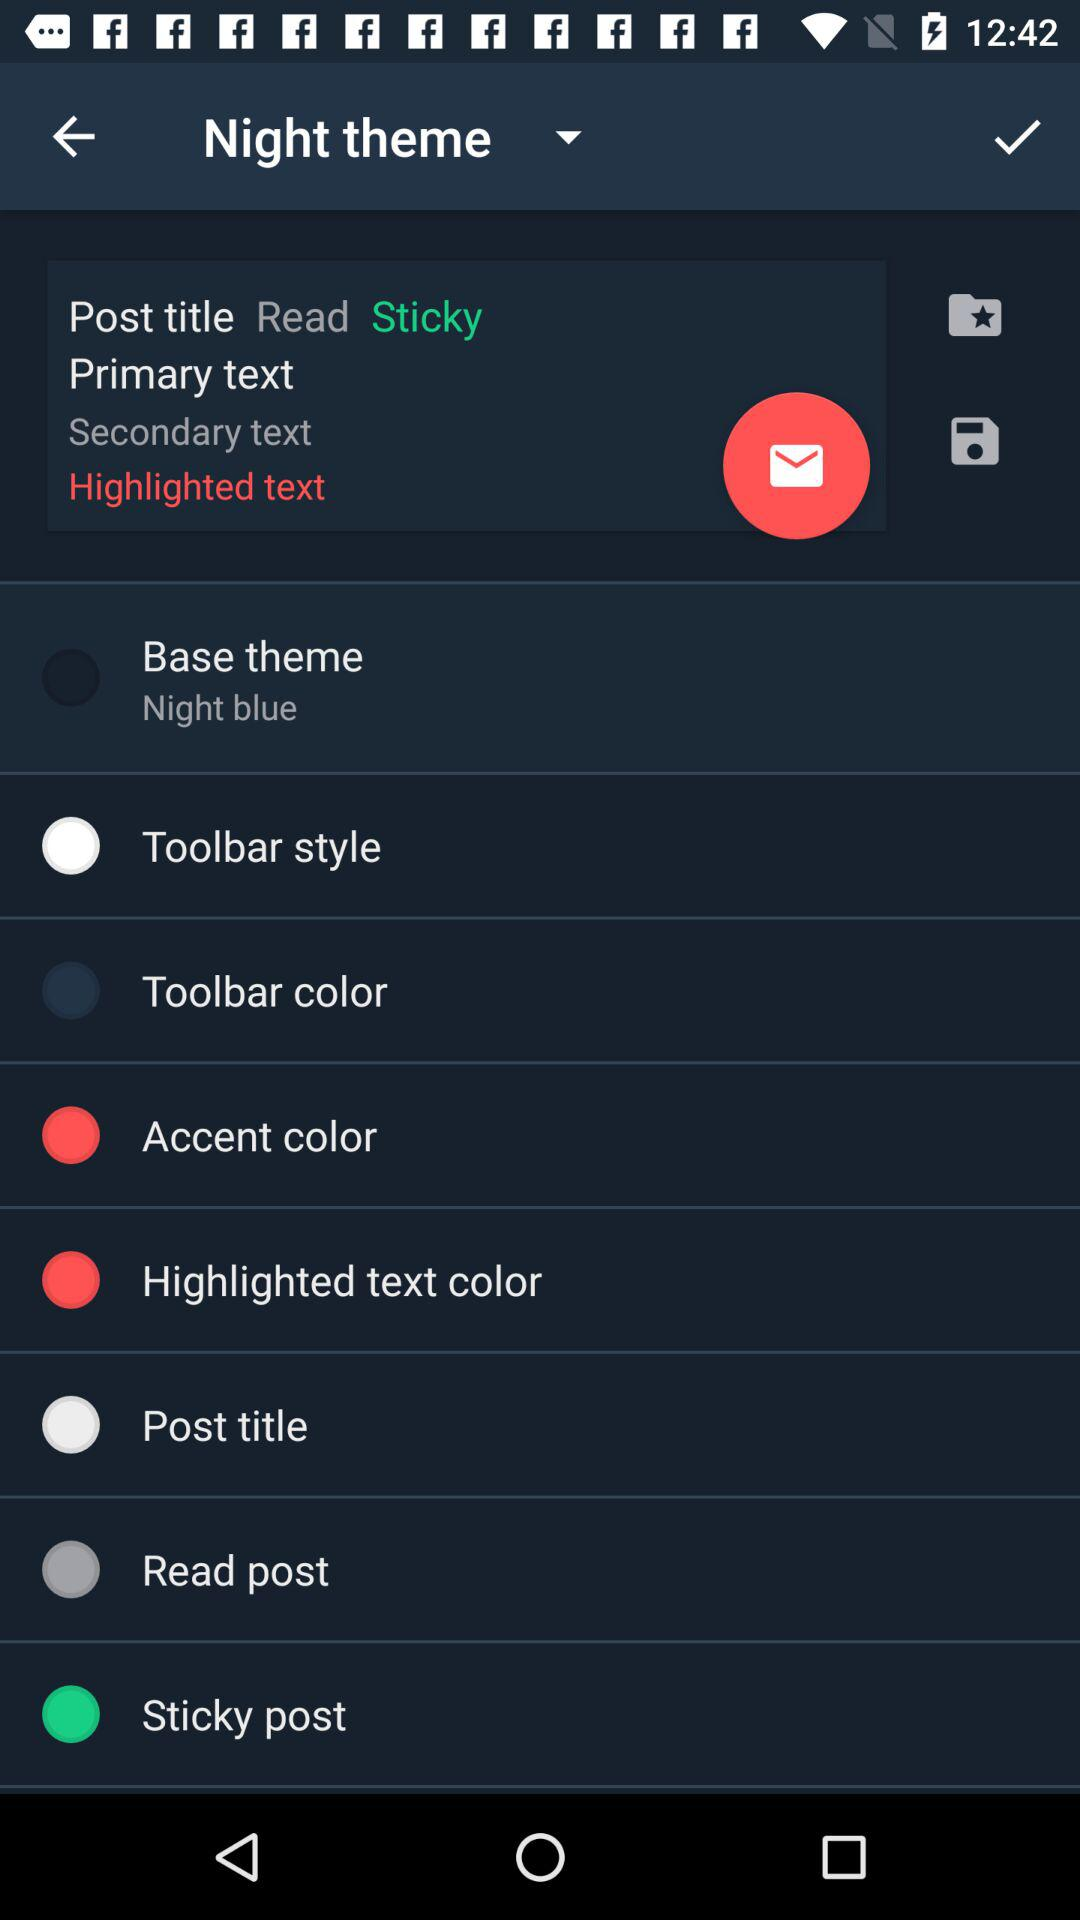What's the color of the base theme? The color of the base theme is "Night blue". 